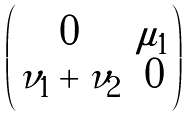Convert formula to latex. <formula><loc_0><loc_0><loc_500><loc_500>\begin{pmatrix} 0 & \mu _ { 1 } \\ \nu _ { 1 } + \nu _ { 2 } & 0 \end{pmatrix}</formula> 